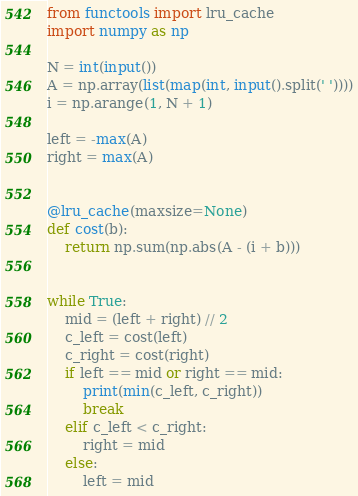Convert code to text. <code><loc_0><loc_0><loc_500><loc_500><_Python_>from functools import lru_cache
import numpy as np

N = int(input())
A = np.array(list(map(int, input().split(' '))))
i = np.arange(1, N + 1)

left = -max(A)
right = max(A)


@lru_cache(maxsize=None)
def cost(b):
    return np.sum(np.abs(A - (i + b)))


while True:
    mid = (left + right) // 2
    c_left = cost(left)
    c_right = cost(right)
    if left == mid or right == mid:
        print(min(c_left, c_right))
        break
    elif c_left < c_right:
        right = mid
    else:
        left = mid
</code> 